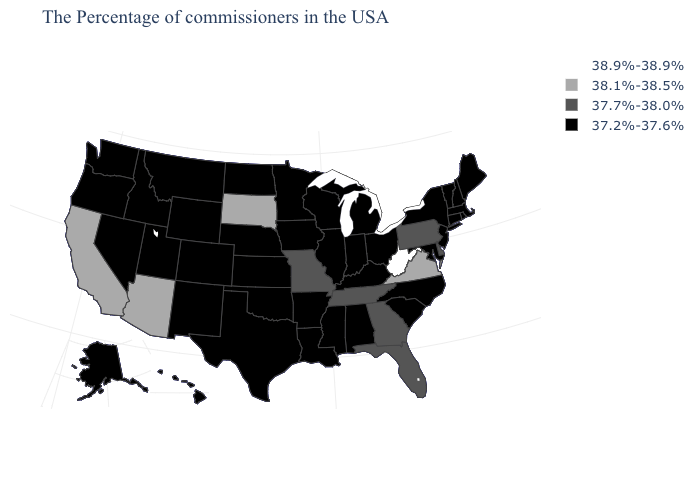Which states hav the highest value in the Northeast?
Quick response, please. Pennsylvania. What is the value of Wisconsin?
Quick response, please. 37.2%-37.6%. What is the lowest value in states that border South Carolina?
Be succinct. 37.2%-37.6%. What is the lowest value in states that border Pennsylvania?
Concise answer only. 37.2%-37.6%. What is the value of North Carolina?
Keep it brief. 37.2%-37.6%. Does the map have missing data?
Be succinct. No. Name the states that have a value in the range 38.1%-38.5%?
Quick response, please. Virginia, South Dakota, Arizona, California. Does Michigan have the same value as Delaware?
Write a very short answer. No. Does Massachusetts have the same value as California?
Quick response, please. No. What is the value of North Carolina?
Give a very brief answer. 37.2%-37.6%. Does Pennsylvania have the lowest value in the Northeast?
Concise answer only. No. What is the value of North Dakota?
Keep it brief. 37.2%-37.6%. Name the states that have a value in the range 37.7%-38.0%?
Give a very brief answer. Delaware, Pennsylvania, Florida, Georgia, Tennessee, Missouri. Name the states that have a value in the range 38.1%-38.5%?
Quick response, please. Virginia, South Dakota, Arizona, California. Does the map have missing data?
Answer briefly. No. 